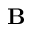<formula> <loc_0><loc_0><loc_500><loc_500>B</formula> 